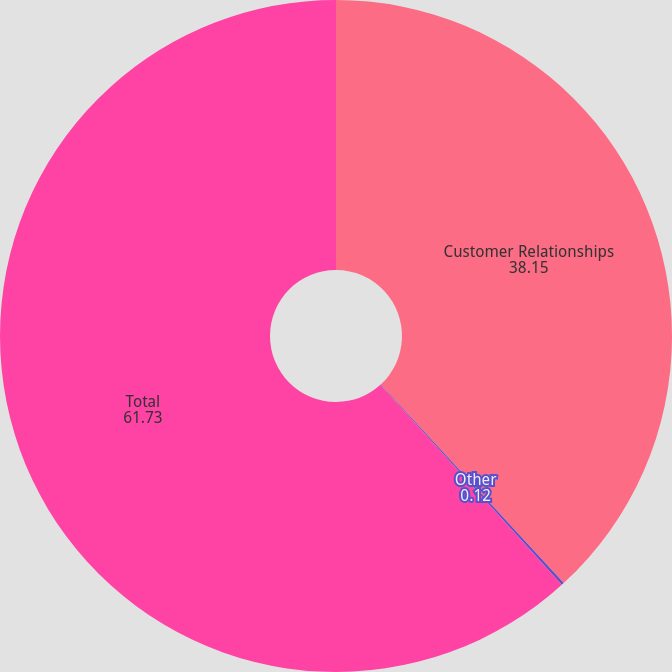Convert chart. <chart><loc_0><loc_0><loc_500><loc_500><pie_chart><fcel>Customer Relationships<fcel>Other<fcel>Total<nl><fcel>38.15%<fcel>0.12%<fcel>61.73%<nl></chart> 